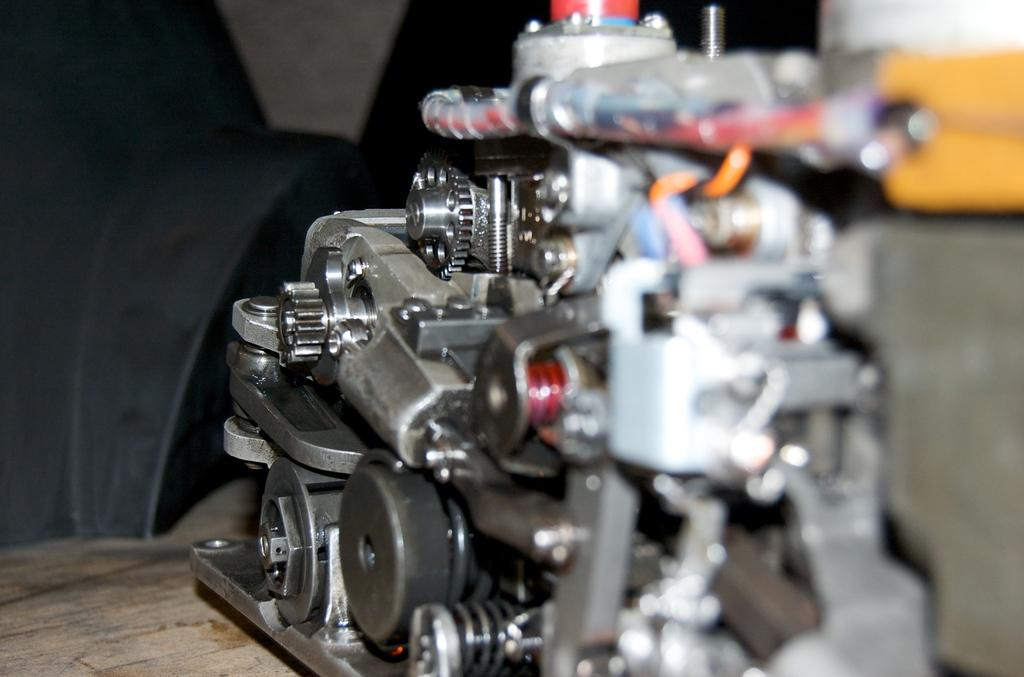What is the main subject of the image? The main subject of the image is a vehicle engine. Where is the vehicle engine located in the image? The vehicle engine is present on a table. How does the vehicle engine express hate in the image? The vehicle engine does not express hate in the image, as it is an inanimate object and cannot express emotions. 